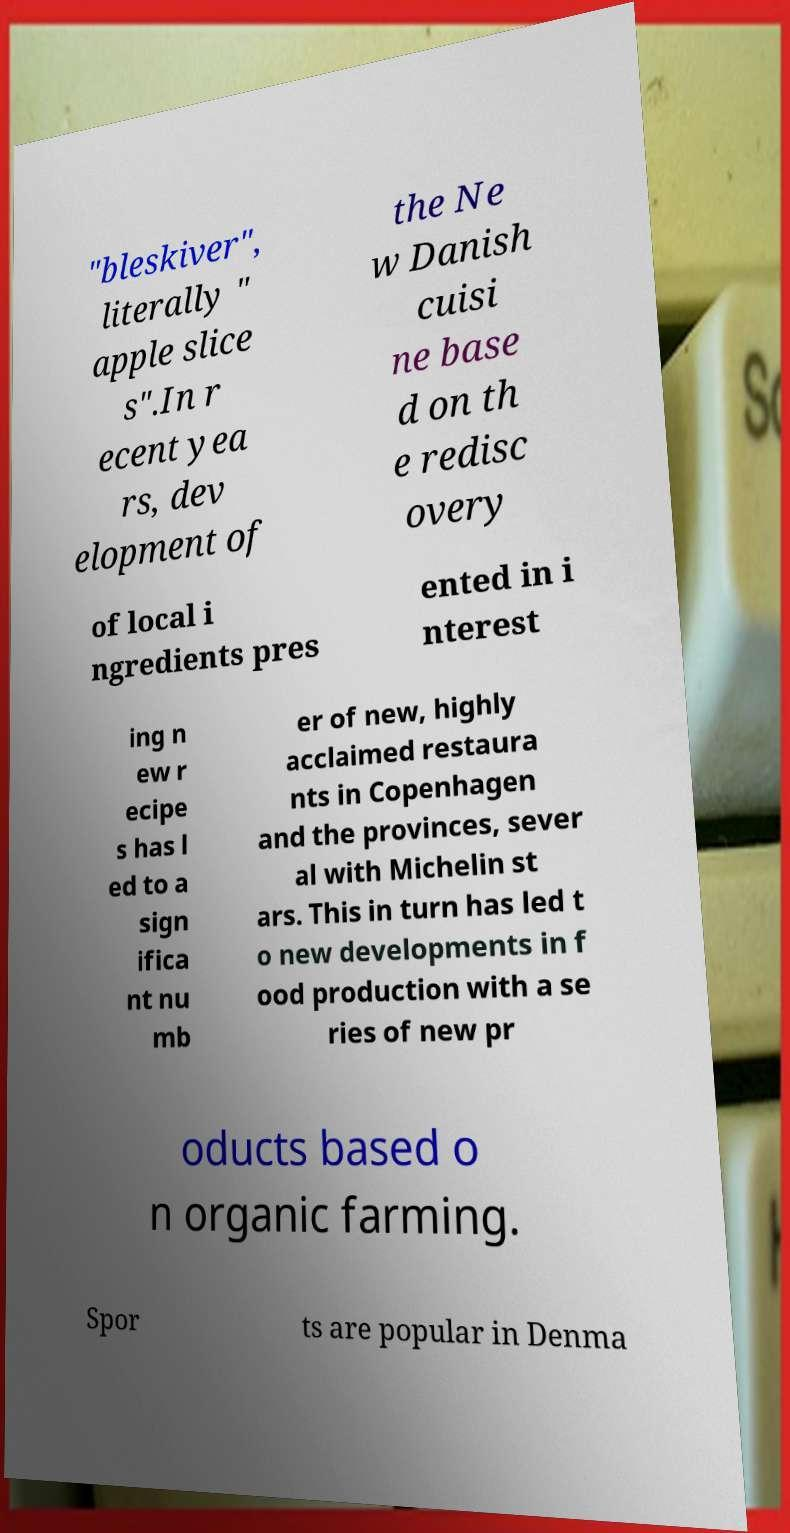Could you extract and type out the text from this image? "bleskiver", literally " apple slice s".In r ecent yea rs, dev elopment of the Ne w Danish cuisi ne base d on th e redisc overy of local i ngredients pres ented in i nterest ing n ew r ecipe s has l ed to a sign ifica nt nu mb er of new, highly acclaimed restaura nts in Copenhagen and the provinces, sever al with Michelin st ars. This in turn has led t o new developments in f ood production with a se ries of new pr oducts based o n organic farming. Spor ts are popular in Denma 